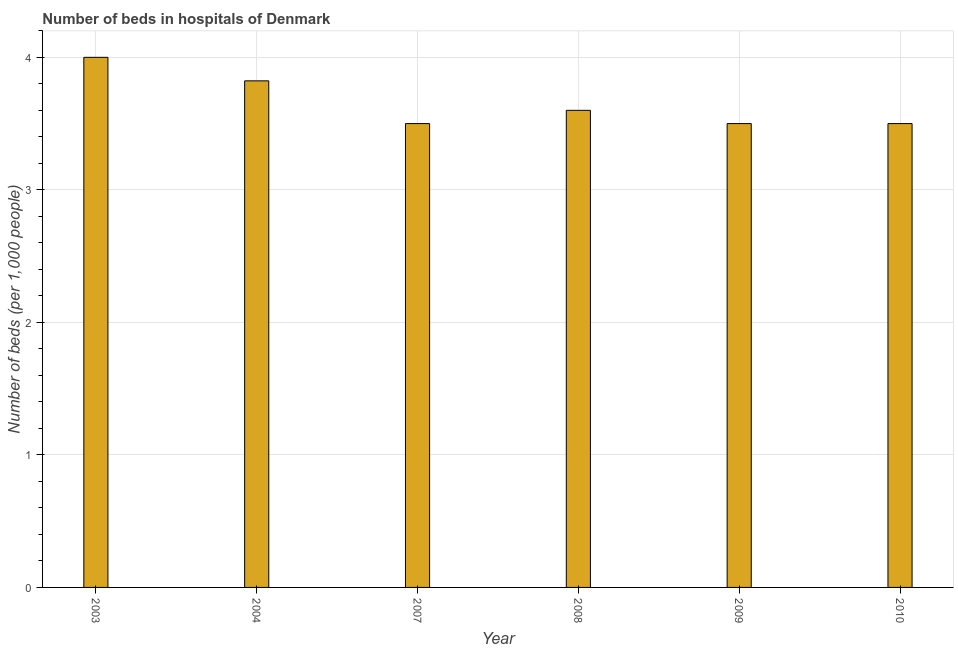What is the title of the graph?
Provide a succinct answer. Number of beds in hospitals of Denmark. What is the label or title of the X-axis?
Ensure brevity in your answer.  Year. What is the label or title of the Y-axis?
Offer a very short reply. Number of beds (per 1,0 people). What is the number of hospital beds in 2008?
Provide a short and direct response. 3.6. What is the sum of the number of hospital beds?
Your answer should be very brief. 21.92. What is the difference between the number of hospital beds in 2007 and 2010?
Provide a short and direct response. 0. What is the average number of hospital beds per year?
Make the answer very short. 3.65. What is the median number of hospital beds?
Provide a short and direct response. 3.55. Do a majority of the years between 2007 and 2004 (inclusive) have number of hospital beds greater than 0.6 %?
Offer a terse response. No. What is the difference between the highest and the second highest number of hospital beds?
Your response must be concise. 0.18. In how many years, is the number of hospital beds greater than the average number of hospital beds taken over all years?
Keep it short and to the point. 2. How many bars are there?
Provide a succinct answer. 6. Are all the bars in the graph horizontal?
Your answer should be very brief. No. What is the Number of beds (per 1,000 people) in 2004?
Give a very brief answer. 3.82. What is the Number of beds (per 1,000 people) in 2008?
Give a very brief answer. 3.6. What is the Number of beds (per 1,000 people) of 2009?
Give a very brief answer. 3.5. What is the difference between the Number of beds (per 1,000 people) in 2003 and 2004?
Give a very brief answer. 0.18. What is the difference between the Number of beds (per 1,000 people) in 2003 and 2008?
Provide a short and direct response. 0.4. What is the difference between the Number of beds (per 1,000 people) in 2003 and 2009?
Ensure brevity in your answer.  0.5. What is the difference between the Number of beds (per 1,000 people) in 2004 and 2007?
Your answer should be compact. 0.32. What is the difference between the Number of beds (per 1,000 people) in 2004 and 2008?
Keep it short and to the point. 0.22. What is the difference between the Number of beds (per 1,000 people) in 2004 and 2009?
Your answer should be compact. 0.32. What is the difference between the Number of beds (per 1,000 people) in 2004 and 2010?
Provide a succinct answer. 0.32. What is the ratio of the Number of beds (per 1,000 people) in 2003 to that in 2004?
Keep it short and to the point. 1.05. What is the ratio of the Number of beds (per 1,000 people) in 2003 to that in 2007?
Make the answer very short. 1.14. What is the ratio of the Number of beds (per 1,000 people) in 2003 to that in 2008?
Offer a terse response. 1.11. What is the ratio of the Number of beds (per 1,000 people) in 2003 to that in 2009?
Give a very brief answer. 1.14. What is the ratio of the Number of beds (per 1,000 people) in 2003 to that in 2010?
Keep it short and to the point. 1.14. What is the ratio of the Number of beds (per 1,000 people) in 2004 to that in 2007?
Offer a very short reply. 1.09. What is the ratio of the Number of beds (per 1,000 people) in 2004 to that in 2008?
Provide a succinct answer. 1.06. What is the ratio of the Number of beds (per 1,000 people) in 2004 to that in 2009?
Give a very brief answer. 1.09. What is the ratio of the Number of beds (per 1,000 people) in 2004 to that in 2010?
Offer a terse response. 1.09. What is the ratio of the Number of beds (per 1,000 people) in 2007 to that in 2010?
Offer a terse response. 1. What is the ratio of the Number of beds (per 1,000 people) in 2008 to that in 2010?
Offer a very short reply. 1.03. What is the ratio of the Number of beds (per 1,000 people) in 2009 to that in 2010?
Keep it short and to the point. 1. 